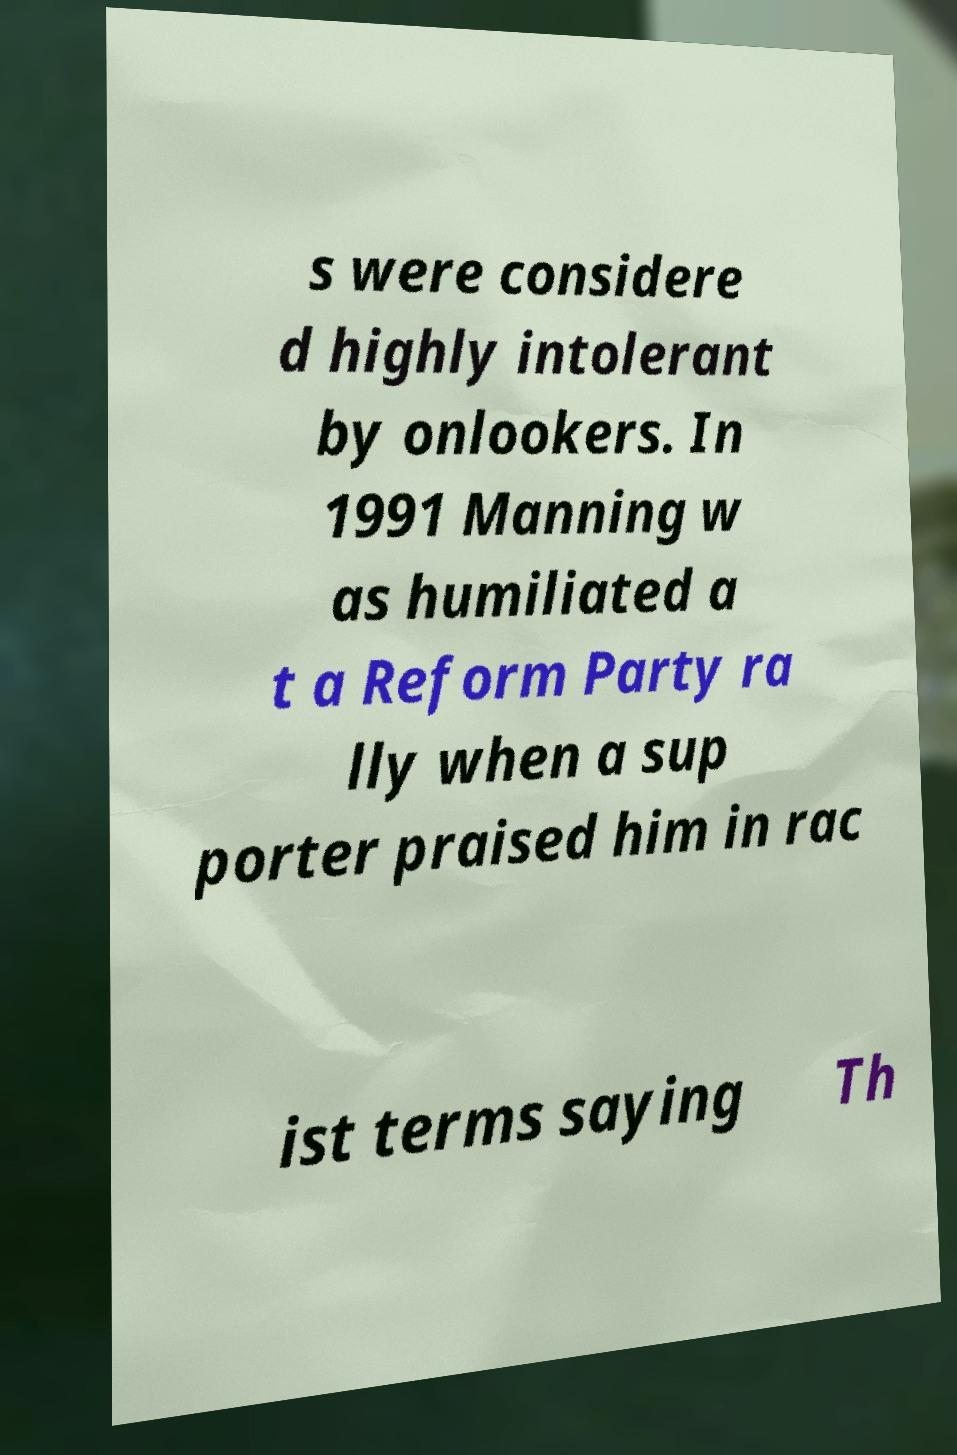Please identify and transcribe the text found in this image. s were considere d highly intolerant by onlookers. In 1991 Manning w as humiliated a t a Reform Party ra lly when a sup porter praised him in rac ist terms saying Th 